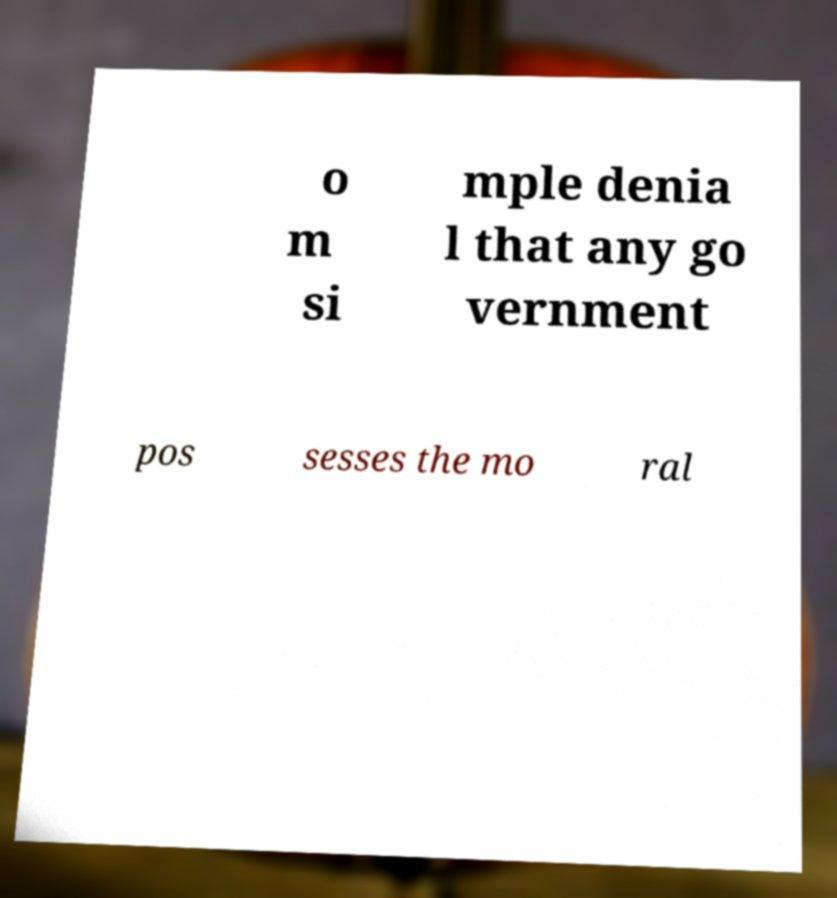There's text embedded in this image that I need extracted. Can you transcribe it verbatim? o m si mple denia l that any go vernment pos sesses the mo ral 